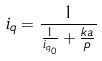<formula> <loc_0><loc_0><loc_500><loc_500>i _ { q } = \frac { 1 } { \frac { 1 } { i _ { q _ { 0 } } } + \frac { k a } { p } }</formula> 